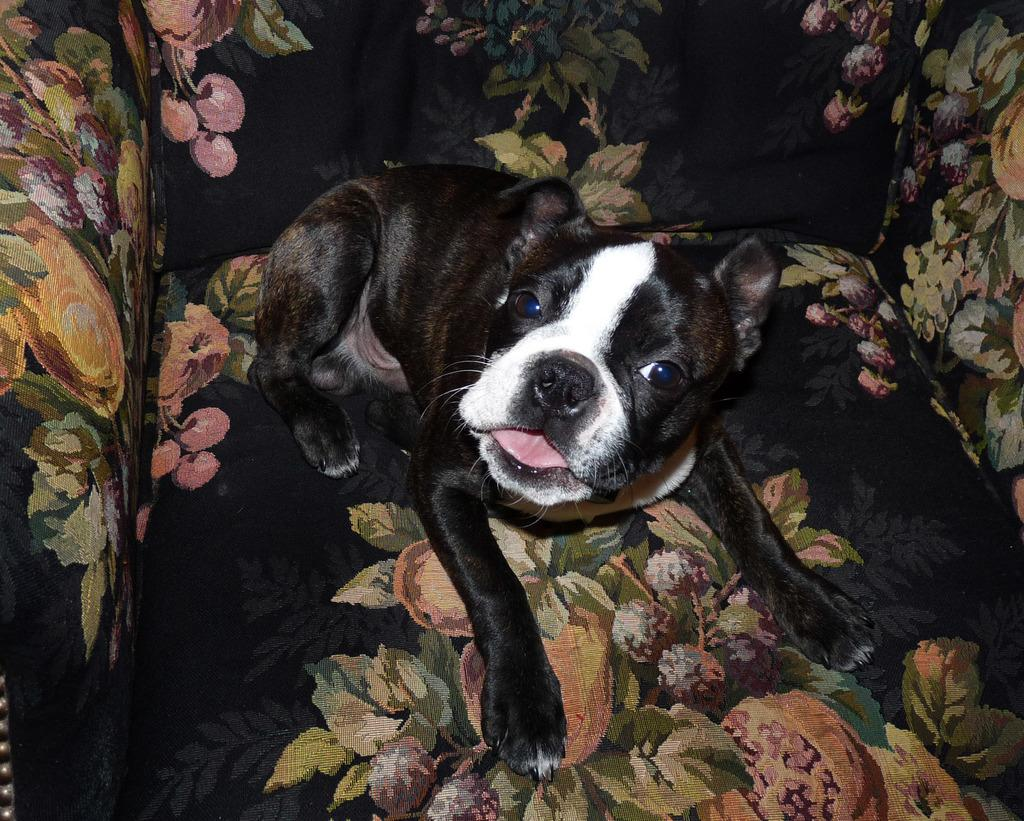What type of animal is in the image? There is a dog in the image. Where is the dog located in the image? The dog is on a chair. What type of doll is the father holding in the image? There is no doll or father present in the image; it only features a dog on a chair. 